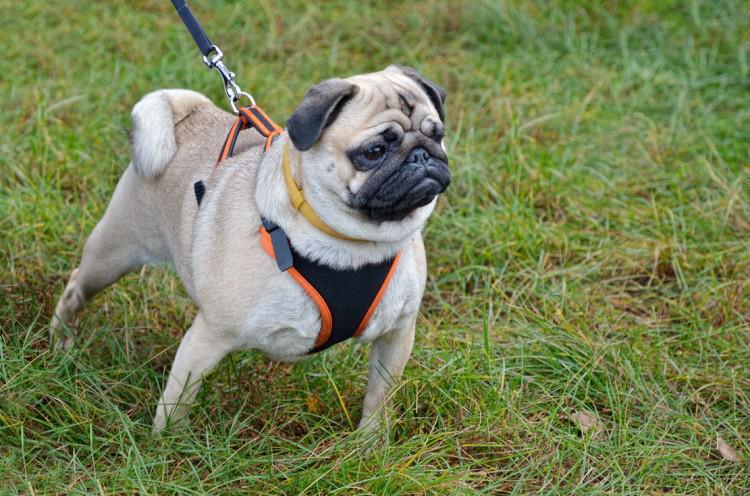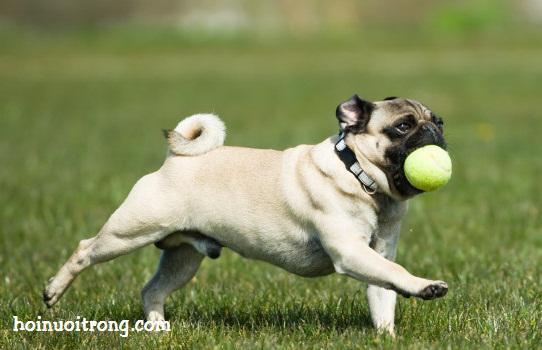The first image is the image on the left, the second image is the image on the right. Evaluate the accuracy of this statement regarding the images: "In the image on the right, there is a dog with a stick in the dog's mouth.". Is it true? Answer yes or no. No. 